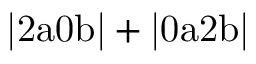<formula> <loc_0><loc_0><loc_500><loc_500>| 2 a 0 b | + | 0 a 2 b |</formula> 